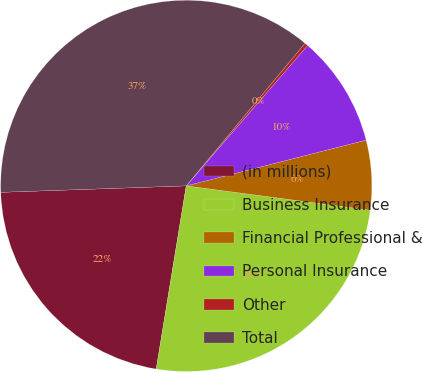Convert chart. <chart><loc_0><loc_0><loc_500><loc_500><pie_chart><fcel>(in millions)<fcel>Business Insurance<fcel>Financial Professional &<fcel>Personal Insurance<fcel>Other<fcel>Total<nl><fcel>21.86%<fcel>25.49%<fcel>6.06%<fcel>9.69%<fcel>0.29%<fcel>36.61%<nl></chart> 